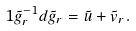Convert formula to latex. <formula><loc_0><loc_0><loc_500><loc_500>1 \tilde { g } _ { r } ^ { - 1 } d \tilde { g } _ { r } = \tilde { u } + \tilde { v } _ { r } .</formula> 